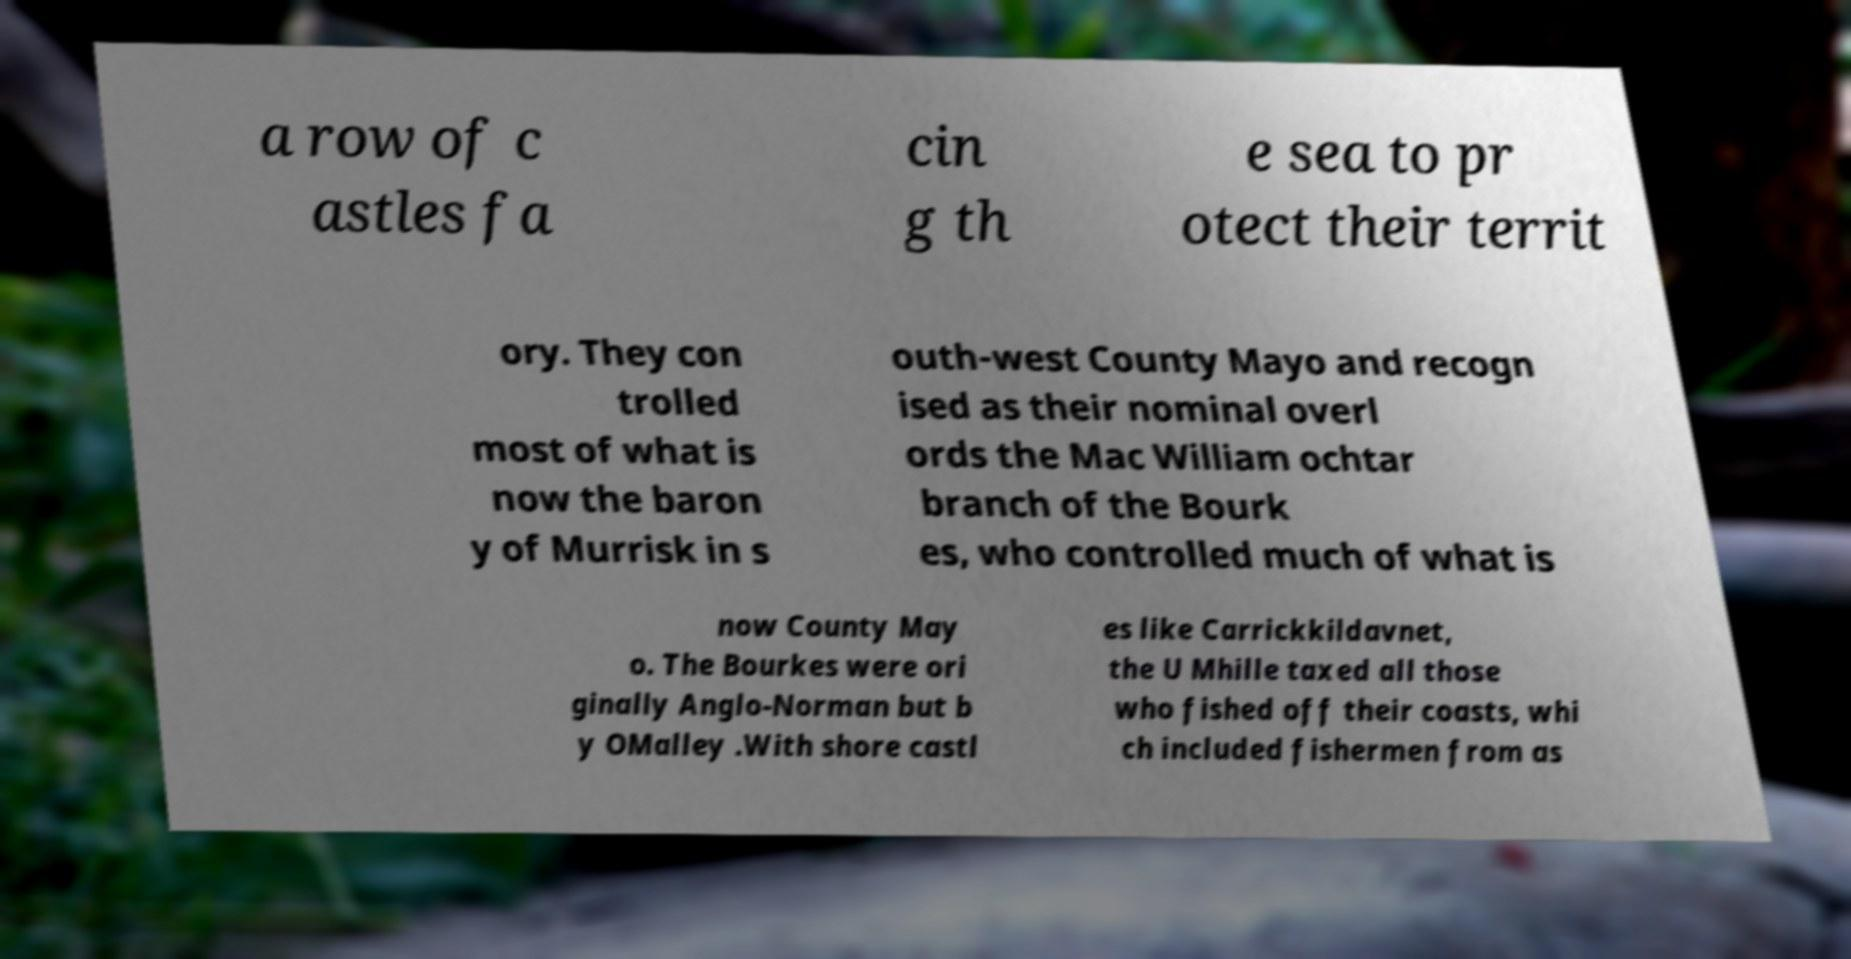For documentation purposes, I need the text within this image transcribed. Could you provide that? a row of c astles fa cin g th e sea to pr otect their territ ory. They con trolled most of what is now the baron y of Murrisk in s outh-west County Mayo and recogn ised as their nominal overl ords the Mac William ochtar branch of the Bourk es, who controlled much of what is now County May o. The Bourkes were ori ginally Anglo-Norman but b y OMalley .With shore castl es like Carrickkildavnet, the U Mhille taxed all those who fished off their coasts, whi ch included fishermen from as 